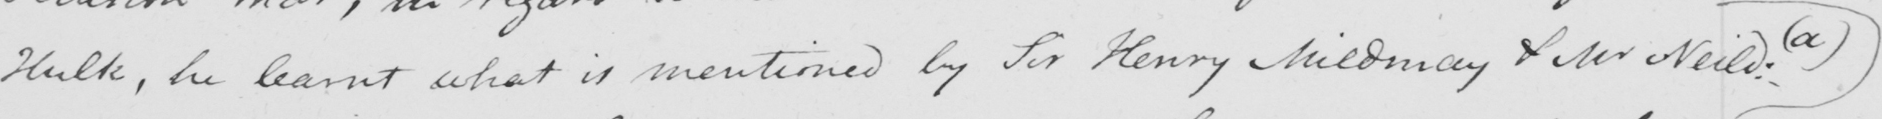What does this handwritten line say? Hulk , he learnt what is mentioned by Sir Henry Mildmay & Mr Neild :   ( a ) 